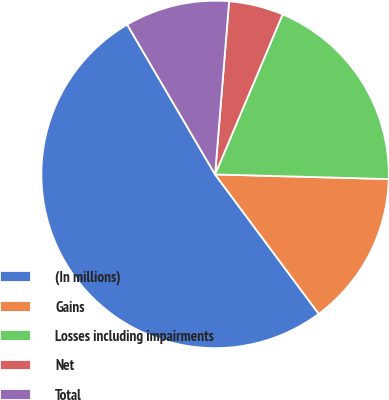Convert chart to OTSL. <chart><loc_0><loc_0><loc_500><loc_500><pie_chart><fcel>(In millions)<fcel>Gains<fcel>Losses including impairments<fcel>Net<fcel>Total<nl><fcel>51.73%<fcel>14.4%<fcel>19.07%<fcel>5.07%<fcel>9.73%<nl></chart> 